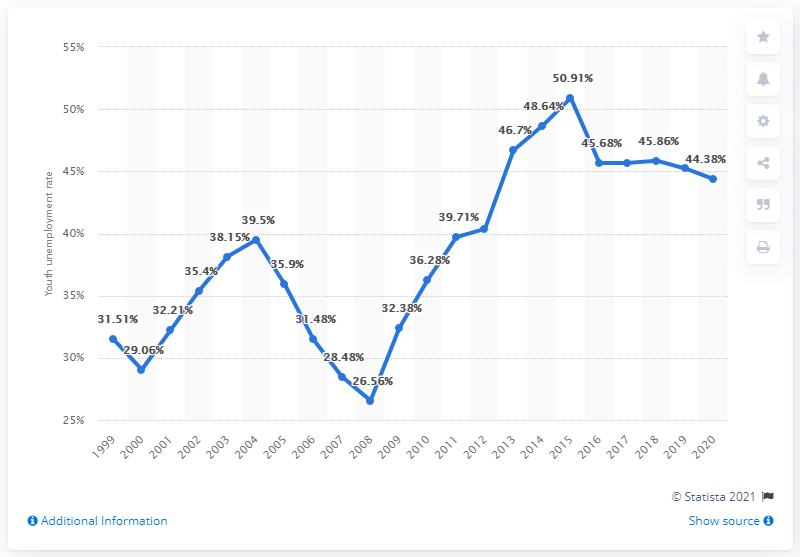Give some essential details in this illustration. In 2020, the youth unemployment rate in St. Lucia was 44.38%. 